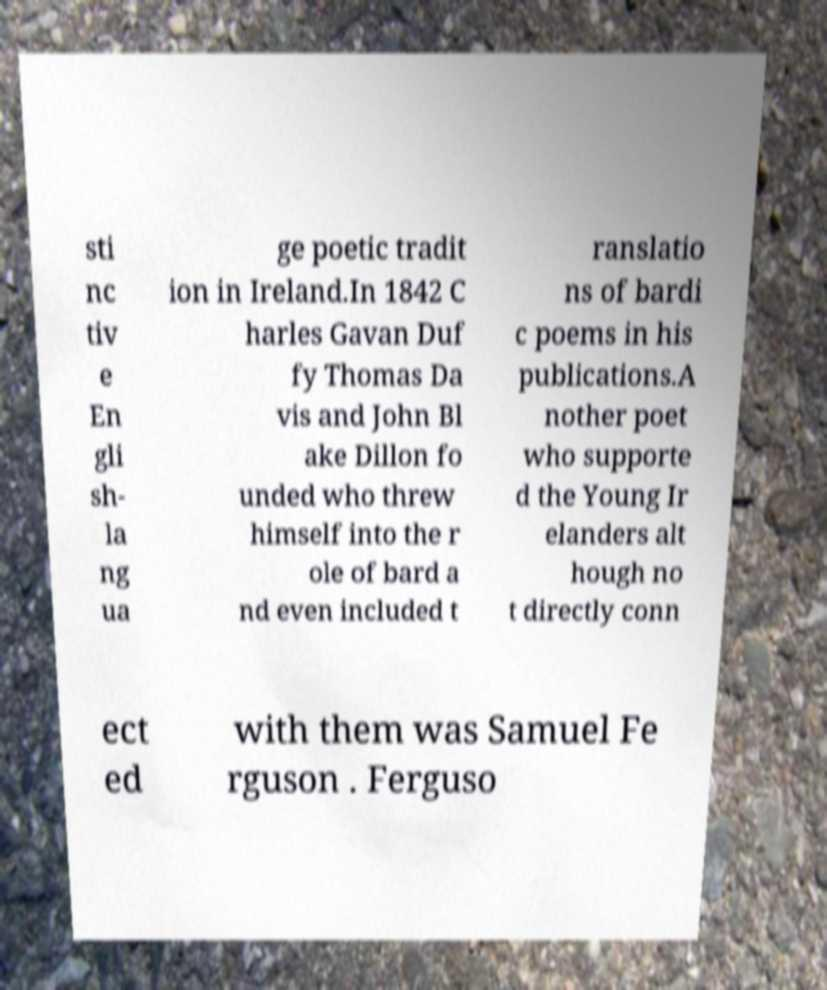Could you extract and type out the text from this image? sti nc tiv e En gli sh- la ng ua ge poetic tradit ion in Ireland.In 1842 C harles Gavan Duf fy Thomas Da vis and John Bl ake Dillon fo unded who threw himself into the r ole of bard a nd even included t ranslatio ns of bardi c poems in his publications.A nother poet who supporte d the Young Ir elanders alt hough no t directly conn ect ed with them was Samuel Fe rguson . Ferguso 